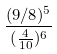<formula> <loc_0><loc_0><loc_500><loc_500>\frac { ( 9 / 8 ) ^ { 5 } } { ( \frac { 4 } { 1 0 } ) ^ { 6 } }</formula> 